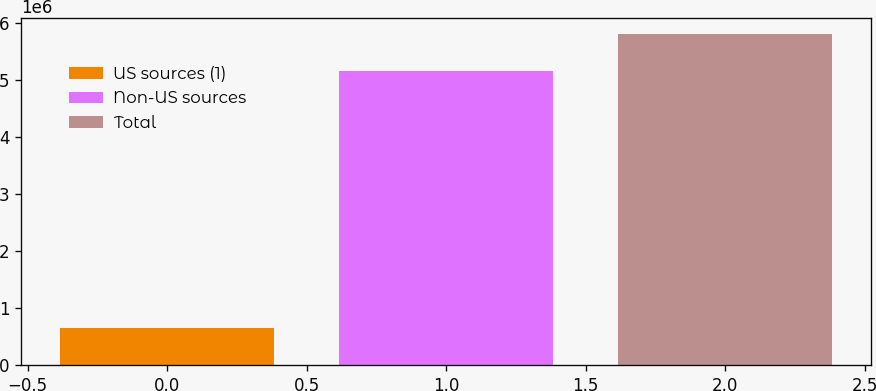Convert chart to OTSL. <chart><loc_0><loc_0><loc_500><loc_500><bar_chart><fcel>US sources (1)<fcel>Non-US sources<fcel>Total<nl><fcel>645943<fcel>5.16215e+06<fcel>5.80809e+06<nl></chart> 